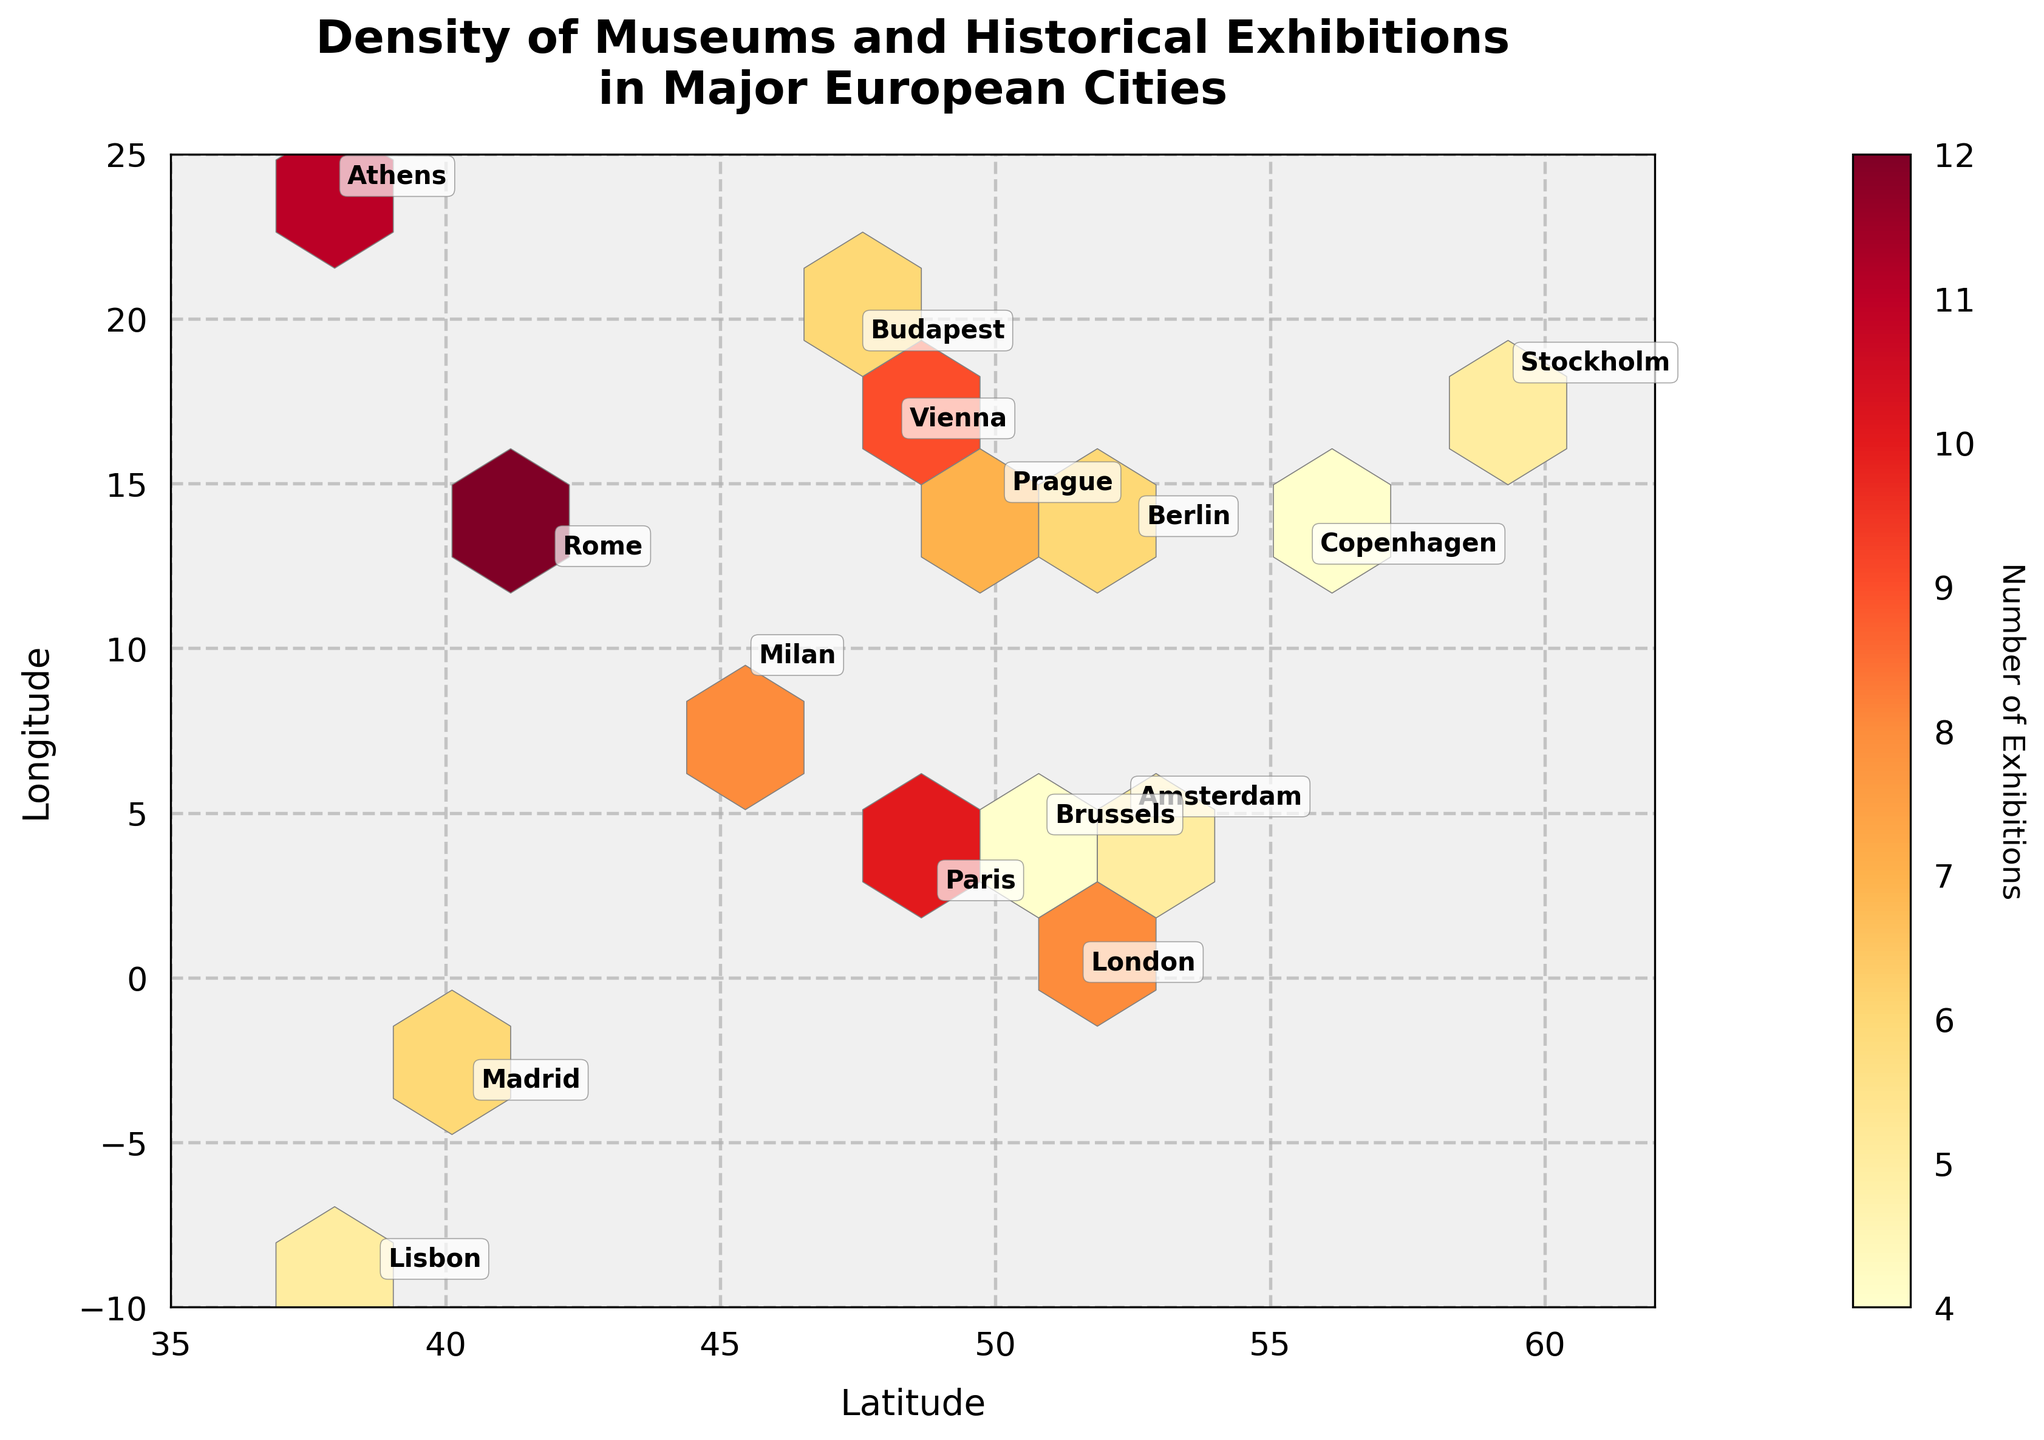What is the title of the plot? Look at the top of the plot where the title is usually located. The plot's title is generally in a prominent font and well-positioned.
Answer: "Density of Museums and Historical Exhibitions in Major European Cities" What does the color gradient in the hexbin plot represent? The color gradient, often indicated in a legend or color bar, represents the values of a specific variable—in this case, the number of exhibitions.
Answer: Number of Exhibitions What range of latitudes does the plot cover? Check the x-axis label and the values annotated along the axis.
Answer: 35 to 62 Which city has the highest density of museums and historical exhibitions related to Ancient Rome? Locate the cities on the plot and refer to the annotations with city names. Identify Rome and note its exhibition count.
Answer: Rome Which historical era has the most cities represented on the plot? Count how many cities correspond to each historical era based on the annotations and their stated eras.
Answer: Renaissance What is the average number of exhibitions for cities located below latitude 50? Identify cities with latitudes below 50 and sum their exhibition numbers, dividing by the count of these cities.
Answer: 8.25 Which city in the Viking Age era is represented on the plot? Locate the annotation with the Viking Age era and note the corresponding city.
Answer: Copenhagen Is there a city with more exhibitions in Ancient Greece than in the Renaissance era? Compare the exhibition numbers for cities associated with Ancient Greece and any with the Renaissance.
Answer: Yes, Athens has 11 exhibitions, more than any Renaissance city Among Berlin, Vienna, and Brussels, which city has the lowest density of museums and historical exhibitions? Identify the counts for Berlin, Vienna, and Brussels and compare them to find the smallest.
Answer: Brussels What's the density difference of exhibitions between Paris and Milan? Identify the exhibition counts for Paris and Milan, then calculate the difference.
Answer: 2 